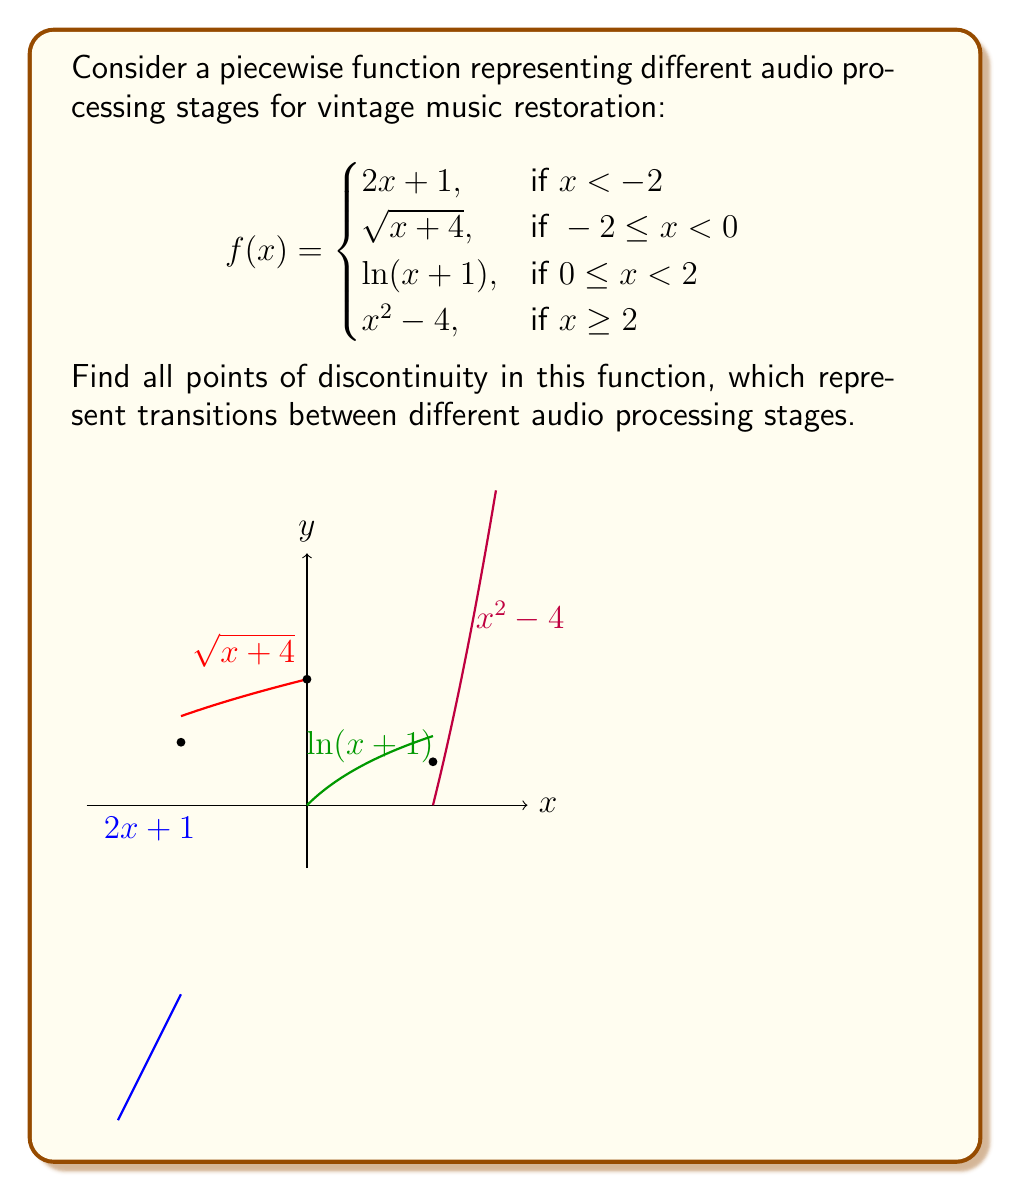Show me your answer to this math problem. To find the points of discontinuity, we need to examine the function at the transition points between different pieces: $x = -2$, $x = 0$, and $x = 2$.

1. At $x = -2$:
   Left limit: $\lim_{x \to -2^-} f(x) = \lim_{x \to -2^-} (2x + 1) = -3$
   Right limit: $\lim_{x \to -2^+} f(x) = \lim_{x \to -2^+} \sqrt{x+4} = \sqrt{2} = \sqrt{2}$
   Since these limits are not equal, there is a discontinuity at $x = -2$.

2. At $x = 0$:
   Left limit: $\lim_{x \to 0^-} f(x) = \lim_{x \to 0^-} \sqrt{x+4} = 2$
   Right limit: $\lim_{x \to 0^+} f(x) = \lim_{x \to 0^+} \ln(x+1) = 0$
   Function value: $f(0) = \ln(0+1) = 0$
   The left limit doesn't equal the right limit, so there is a discontinuity at $x = 0$.

3. At $x = 2$:
   Left limit: $\lim_{x \to 2^-} f(x) = \lim_{x \to 2^-} \ln(x+1) = \ln(3) \approx 1.0986$
   Right limit: $\lim_{x \to 2^+} f(x) = \lim_{x \to 2^+} (x^2 - 4) = 0$
   Function value: $f(2) = 2^2 - 4 = 0$
   The left limit doesn't equal the right limit, so there is a discontinuity at $x = 2$.

Therefore, the function has discontinuities at all transition points: $x = -2$, $x = 0$, and $x = 2$.
Answer: $x = -2$, $x = 0$, and $x = 2$ 